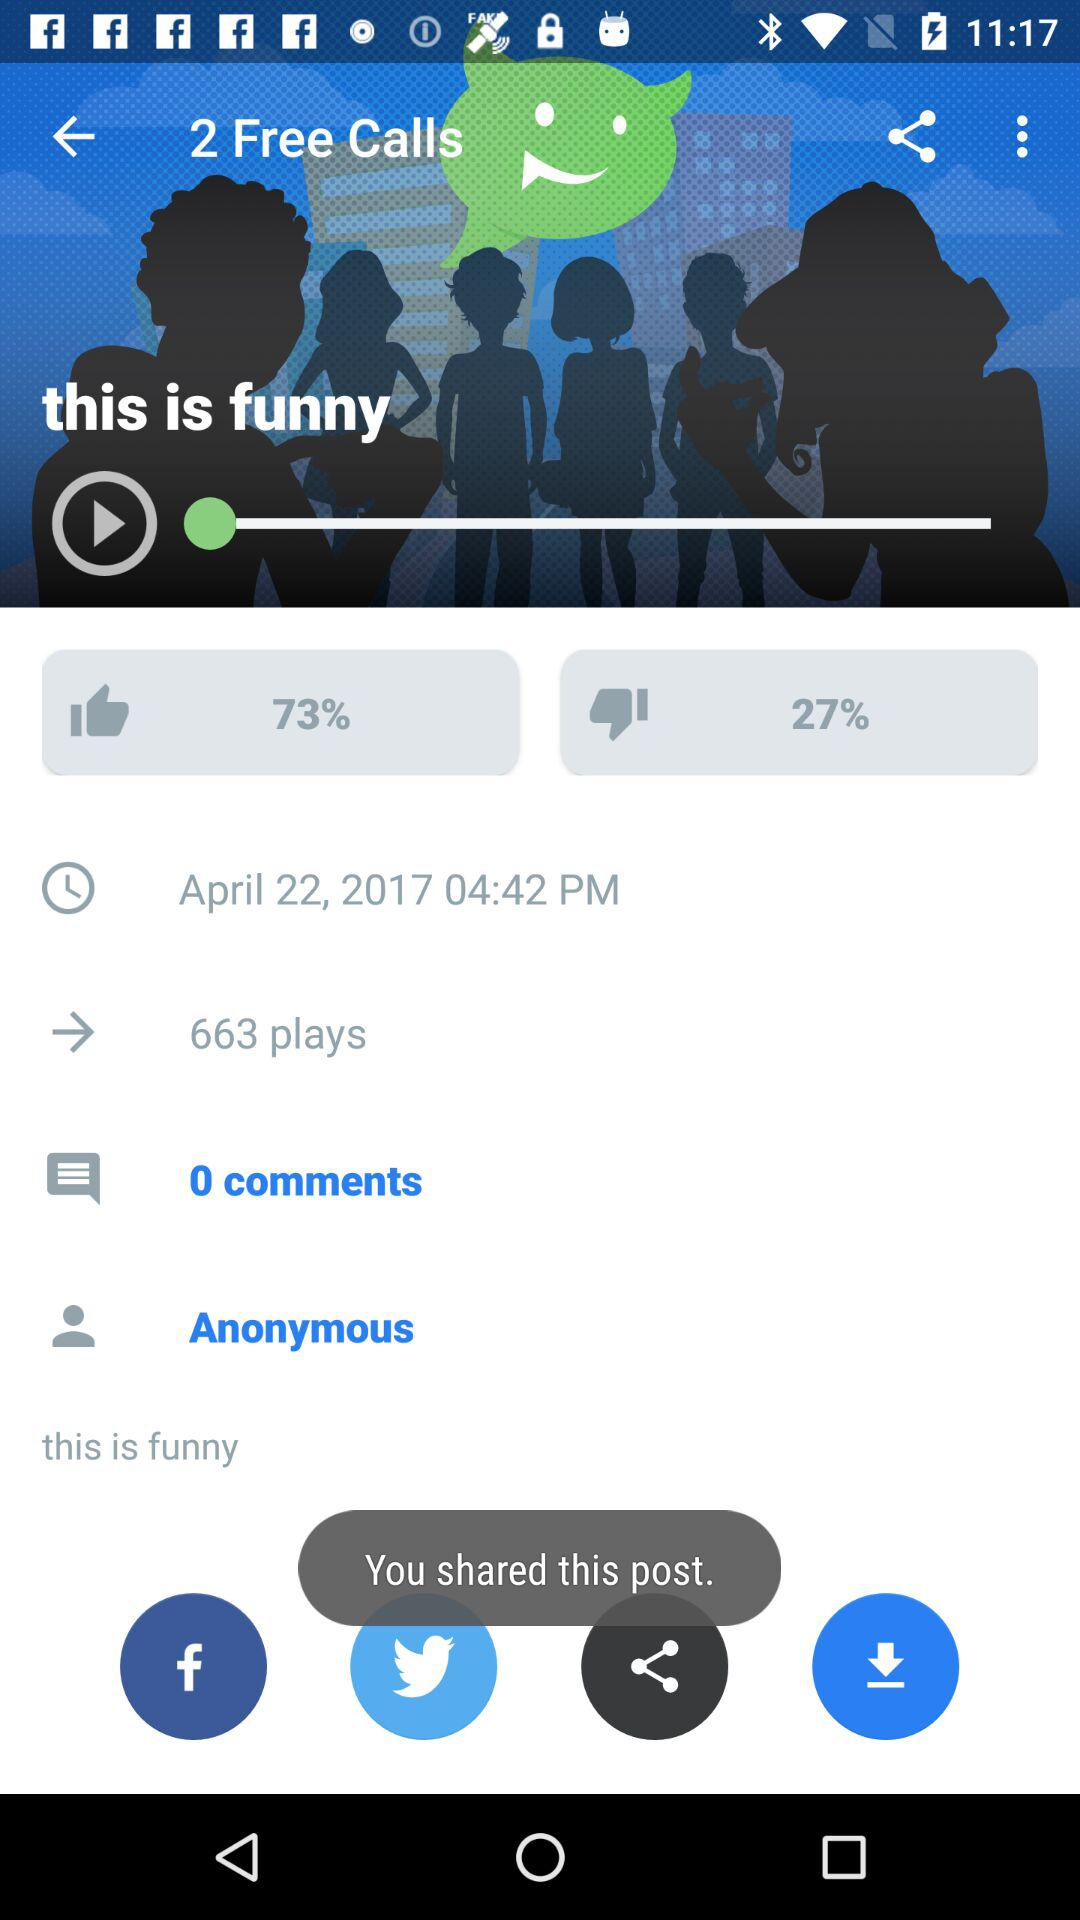How many times has the current song been played? The current song has been played 663 times. 